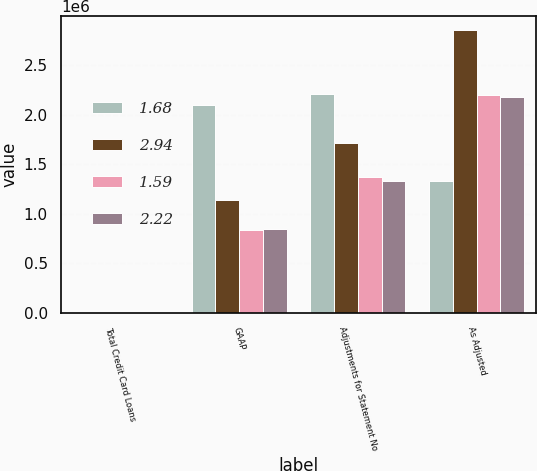Convert chart to OTSL. <chart><loc_0><loc_0><loc_500><loc_500><stacked_bar_chart><ecel><fcel>Total Credit Card Loans<fcel>GAAP<fcel>Adjustments for Statement No<fcel>As Adjusted<nl><fcel>1.68<fcel>2009<fcel>2.09657e+06<fcel>2.20804e+06<fcel>1.3315e+06<nl><fcel>2.94<fcel>2008<fcel>1.13918e+06<fcel>1.71341e+06<fcel>2.85258e+06<nl><fcel>1.59<fcel>2007<fcel>837210<fcel>1.36695e+06<fcel>2.20416e+06<nl><fcel>2.22<fcel>2006<fcel>848645<fcel>1.3315e+06<fcel>2.18015e+06<nl></chart> 